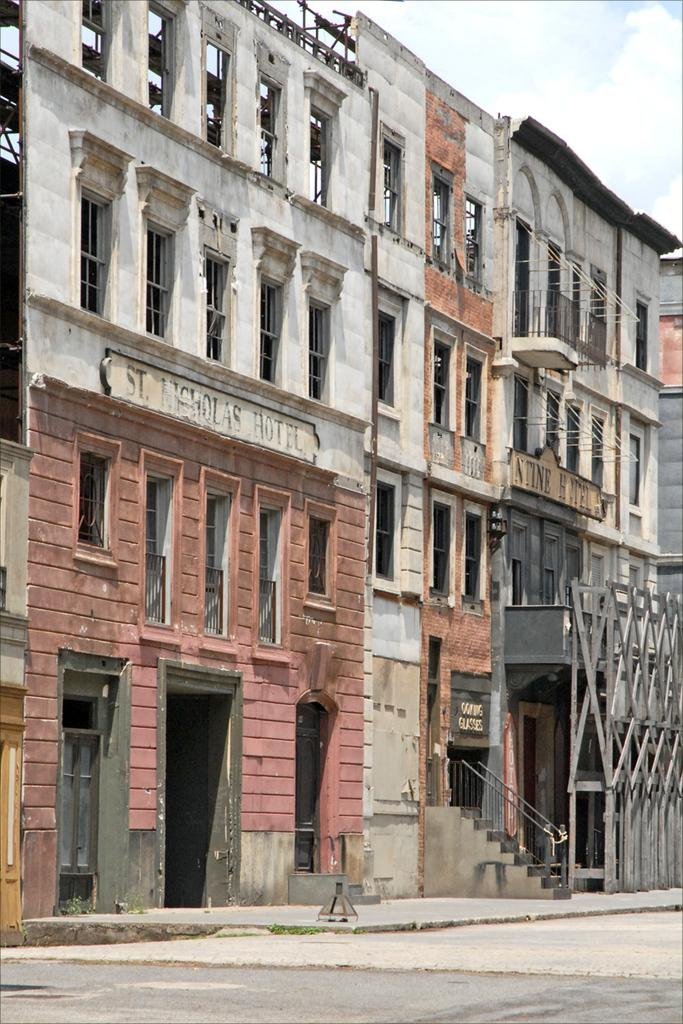What type of structures can be seen in the image? There are buildings in the image. What architectural feature is present in the image? Iron grills and a staircase are present in the image. What safety feature can be observed in the image? To produce the conversation, we first identify the main subjects and objects in the image based on the provided facts. We then formulate questions that focus on the location and characteristics of these subjects and objects, ensuring that each question can be answered definitively with the information given. We avoid yes/no questions and ensure that the language is simple and clear. Absurd Question/Answer: How many balls are being juggled by the person in the image? There is no person or balls present in the image. What type of paper is being used to write on in the image? There is no paper or writing activity present in the image. What type of paper is being used to write on in the image? There is no paper or writing activity present in the image. How many balls are being juggled by the person in the image? There is no person or balls present in the image. 